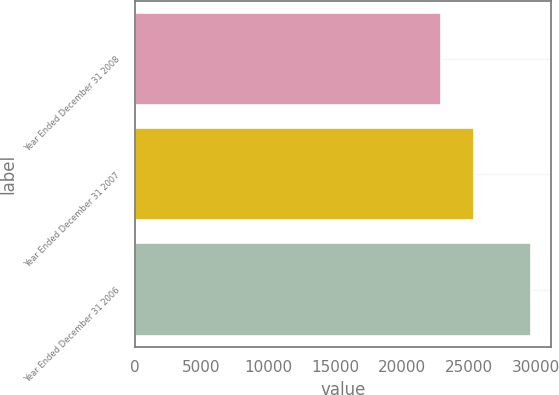Convert chart. <chart><loc_0><loc_0><loc_500><loc_500><bar_chart><fcel>Year Ended December 31 2008<fcel>Year Ended December 31 2007<fcel>Year Ended December 31 2006<nl><fcel>22920<fcel>25418.8<fcel>29671<nl></chart> 